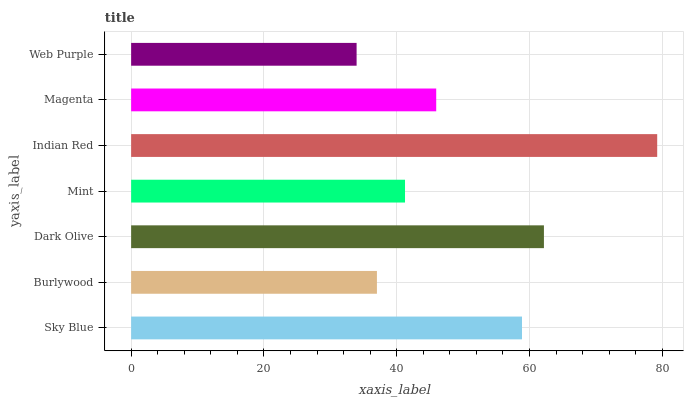Is Web Purple the minimum?
Answer yes or no. Yes. Is Indian Red the maximum?
Answer yes or no. Yes. Is Burlywood the minimum?
Answer yes or no. No. Is Burlywood the maximum?
Answer yes or no. No. Is Sky Blue greater than Burlywood?
Answer yes or no. Yes. Is Burlywood less than Sky Blue?
Answer yes or no. Yes. Is Burlywood greater than Sky Blue?
Answer yes or no. No. Is Sky Blue less than Burlywood?
Answer yes or no. No. Is Magenta the high median?
Answer yes or no. Yes. Is Magenta the low median?
Answer yes or no. Yes. Is Mint the high median?
Answer yes or no. No. Is Burlywood the low median?
Answer yes or no. No. 